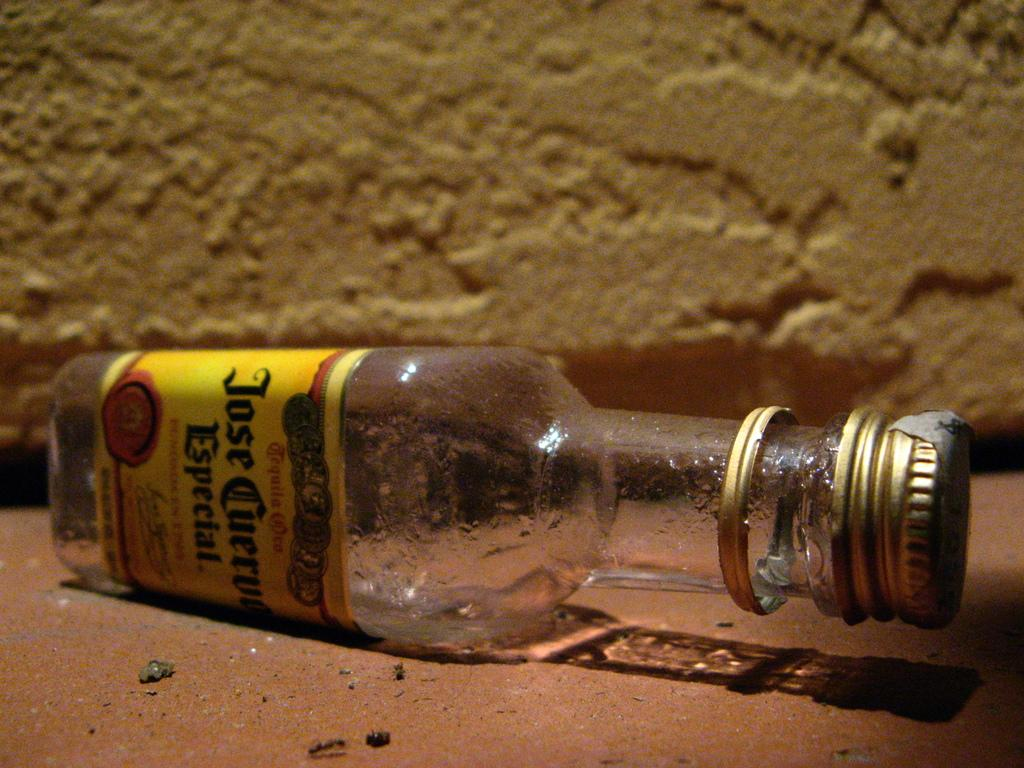What object is present in the image? There is a bottle in the image. What feature does the bottle have? The bottle has a label. What information is on the label? The label contains text. What is visible behind the bottle? There is a wall behind the bottle. How many icicles are hanging from the bottle in the image? There are no icicles present in the image; it features a bottle with a label and a wall as the background. 